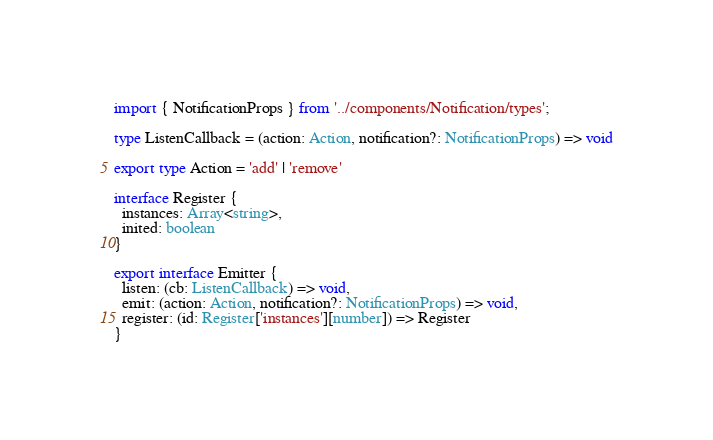<code> <loc_0><loc_0><loc_500><loc_500><_TypeScript_>
import { NotificationProps } from '../components/Notification/types';

type ListenCallback = (action: Action, notification?: NotificationProps) => void

export type Action = 'add' | 'remove'

interface Register { 
  instances: Array<string>, 
  inited: boolean
}

export interface Emitter { 
  listen: (cb: ListenCallback) => void, 
  emit: (action: Action, notification?: NotificationProps) => void, 
  register: (id: Register['instances'][number]) => Register
}</code> 